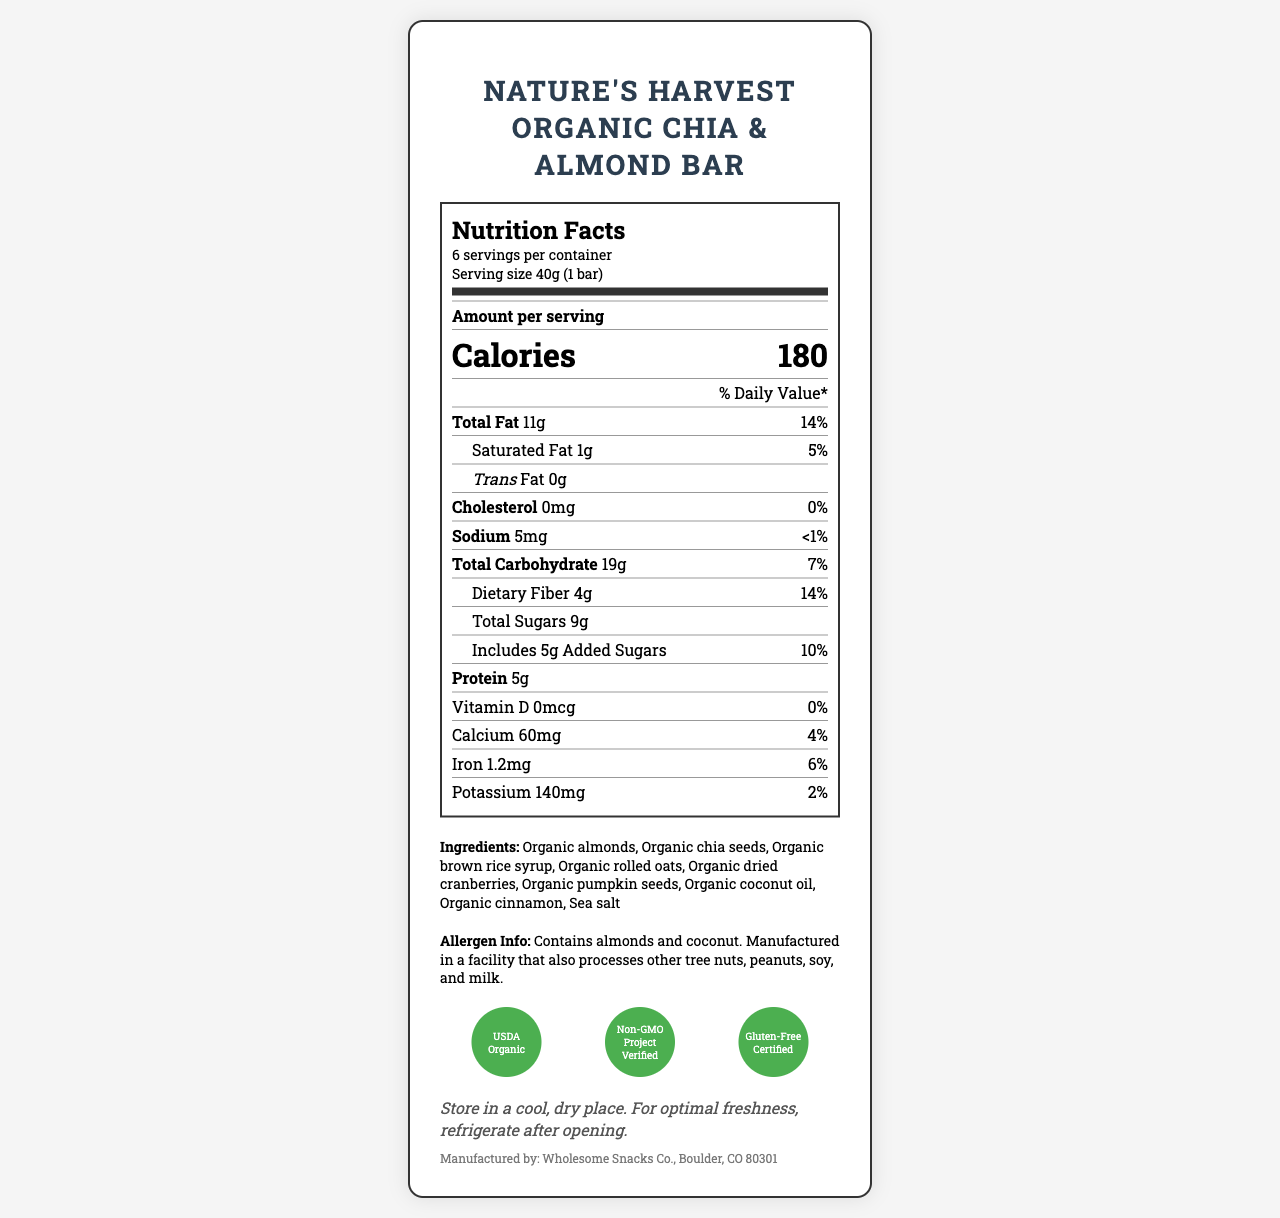what is the serving size for the snack bar? The serving size is mentioned under the "Serving size" label as 40g, which equals 1 bar.
Answer: 40g (1 bar) how many servings are in one container? The number of servings per container is specified as 6.
Answer: 6 what are the total carbohydrates per serving? The amount of total carbohydrates per serving is listed as 19g.
Answer: 19g how much protein does this bar contain? The protein content is indicated as 5g per serving.
Answer: 5g which two ingredients are highlighted as allergens? The allergen information states that the bar contains almonds and coconut.
Answer: Almonds and Coconut how many calories are in each serving of the snack bar? The calories per serving are listed as 180.
Answer: 180 what percentage of the daily value of dietary fiber does the bar provide? The daily value percentage for dietary fiber is given as 14%.
Answer: 14% if you eat the entire container, how many grams of total fat will you consume? 11g of total fat per serving multiplied by 6 servings per container equals 66g of total fat.
Answer: 66g what certifications does the product have? The certifications are mentioned towards the bottom of the document.
Answer: USDA Organic, Non-GMO Project Verified, Gluten-Free Certified who is the manufacturer of this snack bar? The manufacturer information is provided at the bottom of the document.
Answer: Wholesome Snacks Co., Boulder, CO 80301 what is the daily value percentage of iron per serving? The daily value percentage for iron is stated as 6%.
Answer: 6% which ingredient is not processed in the facility that also handles other tree nuts, peanuts, soy, and milk? The document does not specify which ingredients might not be handled with other allergens.
Answer: Cannot be determined what is the source of sugar in the snack bar? The specifications for added sugar sources are organic brown rice syrup and organic dried cranberries among the ingredients.
Answer: Organic brown rice syrup, Organic dried cranberries what are the storage instructions for this product? The storage instructions specify to store it in a cool, dry place and to refrigerate after opening for optimal freshness.
Answer: Store in a cool, dry place. For optimal freshness, refrigerate after opening. what amount of cholesterol is in the snack bar per serving? The cholesterol content per serving is listed as 0mg.
Answer: 0mg how many certifications does the product have? A. 1 B. 2 C. 3 D. 4 The product has three certifications: USDA Organic, Non-GMO Project Verified, and Gluten-Free Certified.
Answer: C which of the following is not an ingredient in the snack bar? 1. Organic chia seeds 2. Organic almond butter 3. Organic rolled oats 4. Organic dried cranberries Organic almond butter is not listed as an ingredient.
Answer: 2 is the potassium content of the snack bar more than 3% of the daily value? The daily value percentage for potassium is given as 2%, which is less than 3%.
Answer: No describe the main idea of the document. The document includes detailed information about the nutritional facts per serving, the ingredients used, any allergen information, certifications received, storage guidelines, and the manufacturer's contact details.
Answer: The document provides comprehensive nutritional information, ingredient list, allergen info, certifications, storage instructions, and manufacturer details for Nature's Harvest Organic Chia & Almond Bar. what method is used for ingredient sourcing and tracking? The document provided does not include specific methods for ingredient sourcing and tracking.
Answer: Not enough information 